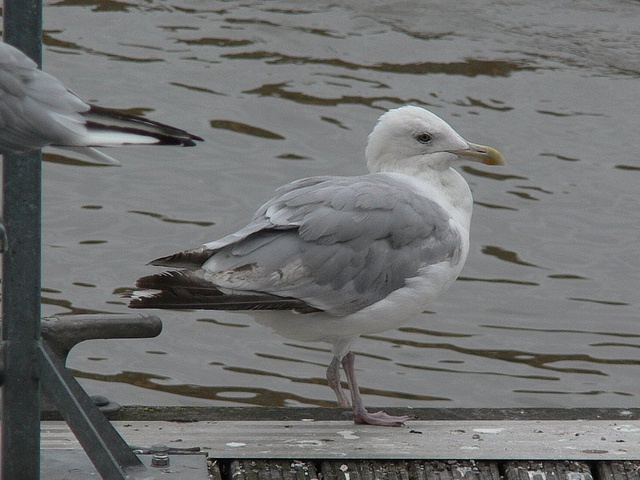Describe the objects in this image and their specific colors. I can see bird in gray, darkgray, black, and lightgray tones and bird in gray and black tones in this image. 